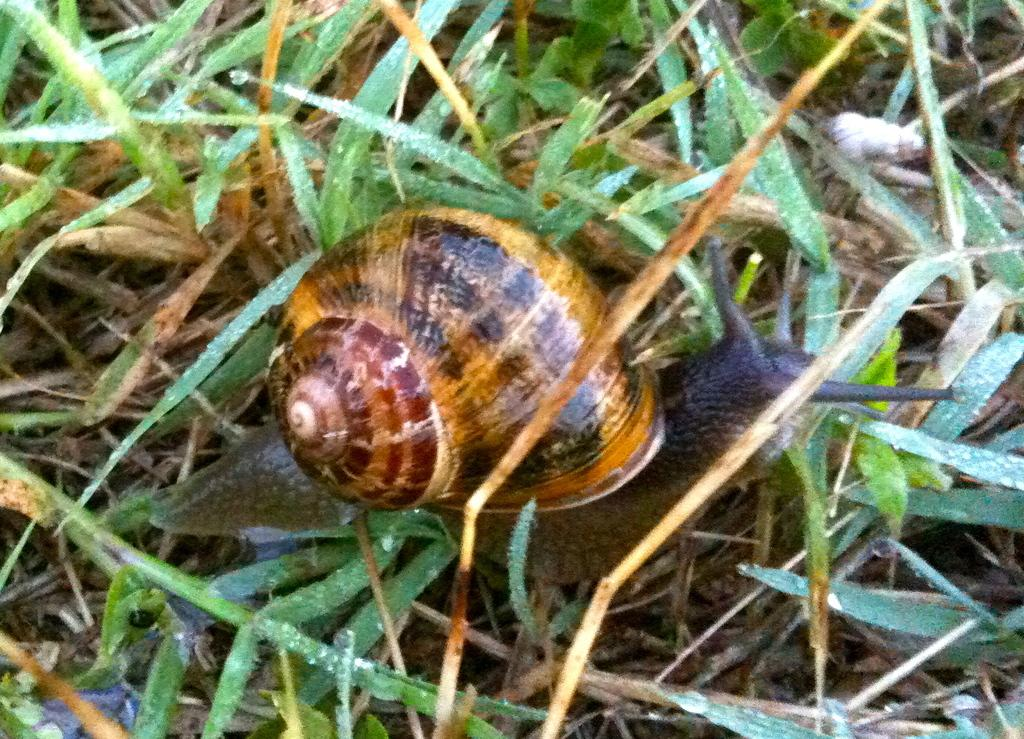What type of animal can be seen on the ground in the image? There is a snail on the ground in the image. What type of vegetation is visible in the image? There is green grass visible at the top of the image. What can be seen on the leaves in the top left of the image? Water drops are present on leaves in the top left of the image. What type of watch is the snail wearing in the image? There is no watch present in the image; the snail is not wearing any accessories. 